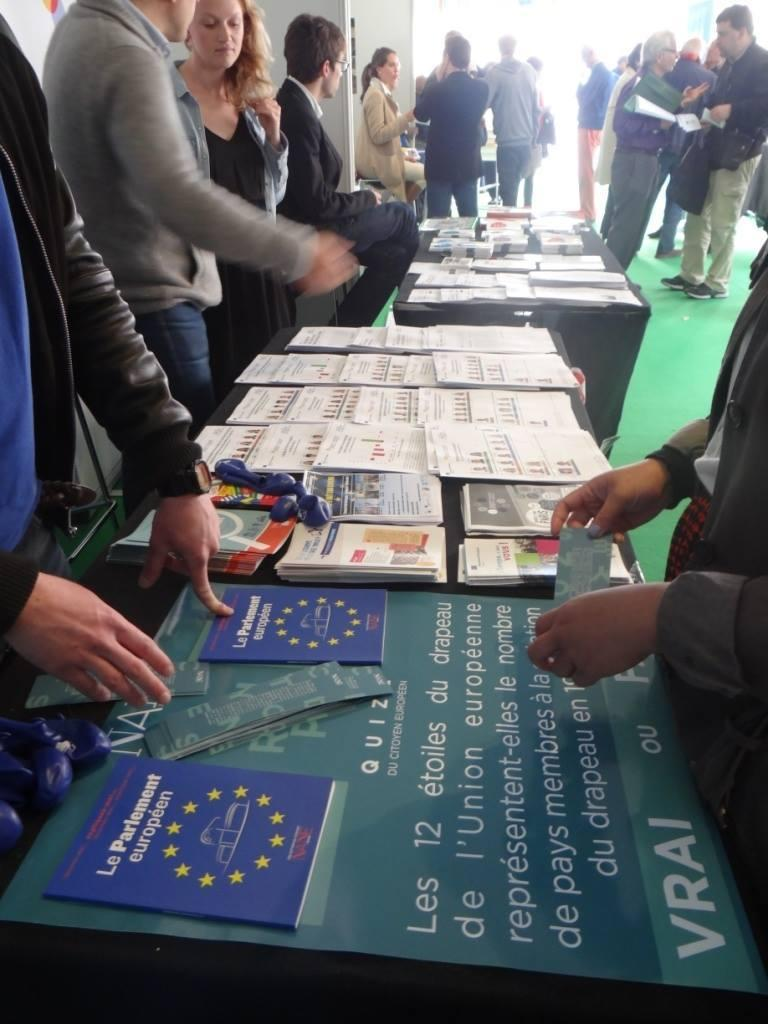Who or what can be seen in the image? There are people in the image. What type of furniture is present in the image? There are tables in the image. What is attached to one of the tables? There is a banner on a table. What else can be found on the tables in the image? There is paper and books on a table. What type of plants can be seen growing on the tables in the image? There are no plants visible on the tables in the image. How many clocks are present on the tables in the image? There are no clocks present on the tables in the image. 